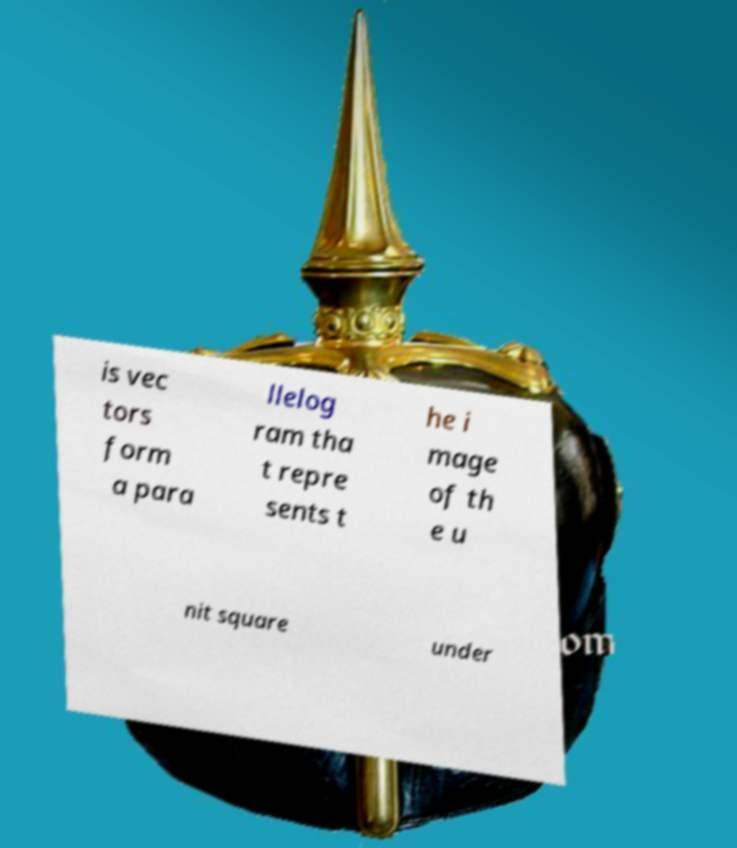Please read and relay the text visible in this image. What does it say? is vec tors form a para llelog ram tha t repre sents t he i mage of th e u nit square under 